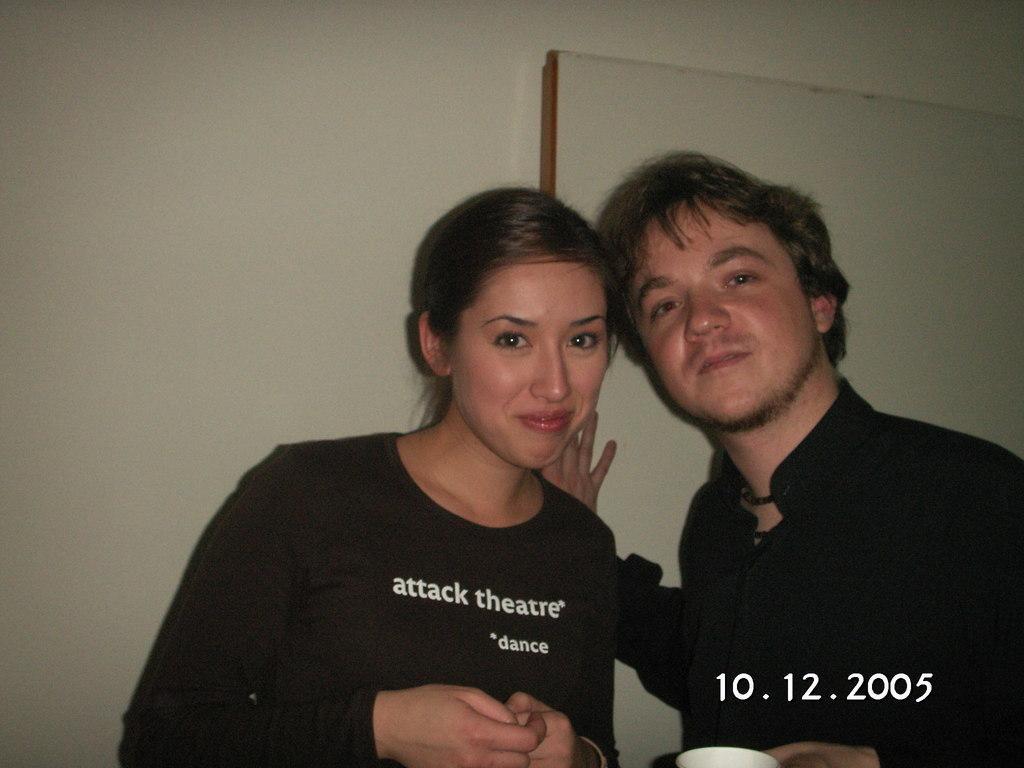Could you give a brief overview of what you see in this image? In this image I can see two people are wearing black color dresses. Background is in white color. 